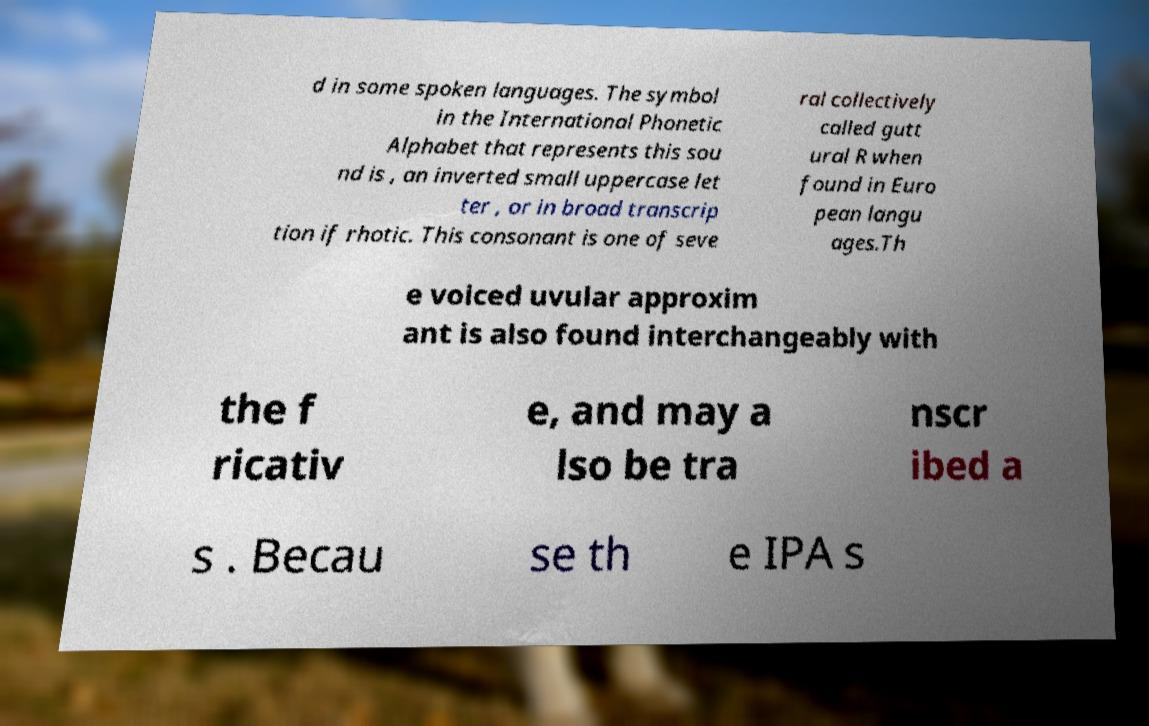Could you assist in decoding the text presented in this image and type it out clearly? d in some spoken languages. The symbol in the International Phonetic Alphabet that represents this sou nd is , an inverted small uppercase let ter , or in broad transcrip tion if rhotic. This consonant is one of seve ral collectively called gutt ural R when found in Euro pean langu ages.Th e voiced uvular approxim ant is also found interchangeably with the f ricativ e, and may a lso be tra nscr ibed a s . Becau se th e IPA s 